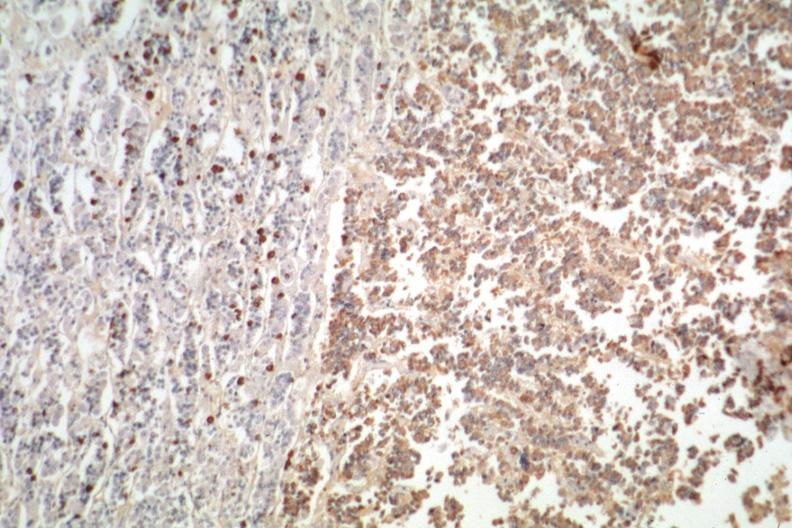does nipple duplication show immunostain for growth hormone stain is positive?
Answer the question using a single word or phrase. No 